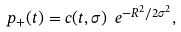<formula> <loc_0><loc_0><loc_500><loc_500>p _ { + } ( t ) = c ( t , \sigma ) \ e ^ { - R ^ { 2 } / 2 \sigma ^ { 2 } } ,</formula> 